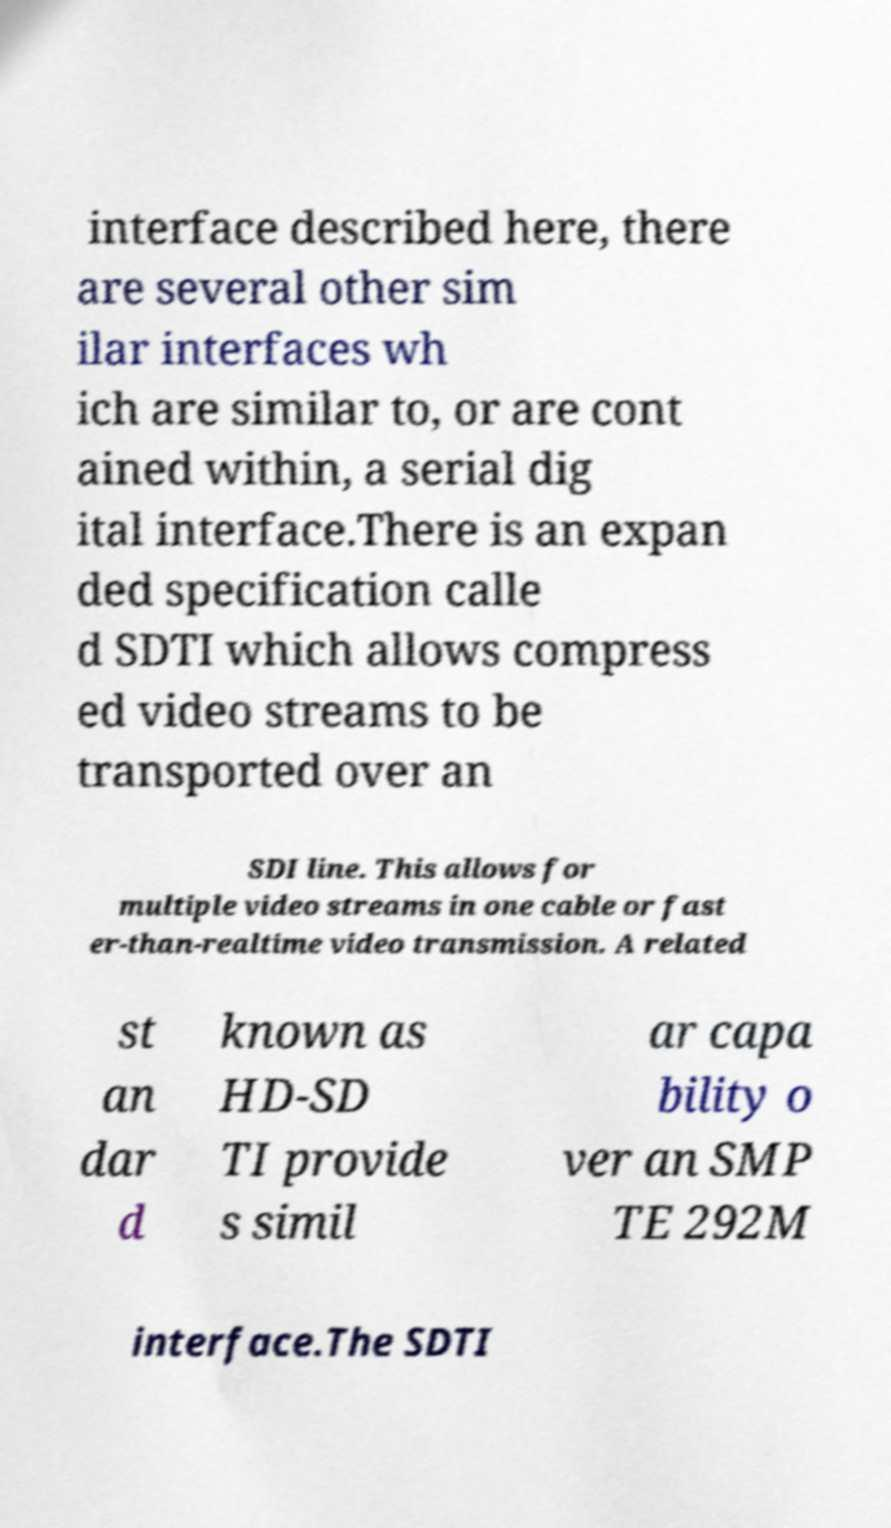Can you read and provide the text displayed in the image?This photo seems to have some interesting text. Can you extract and type it out for me? interface described here, there are several other sim ilar interfaces wh ich are similar to, or are cont ained within, a serial dig ital interface.There is an expan ded specification calle d SDTI which allows compress ed video streams to be transported over an SDI line. This allows for multiple video streams in one cable or fast er-than-realtime video transmission. A related st an dar d known as HD-SD TI provide s simil ar capa bility o ver an SMP TE 292M interface.The SDTI 